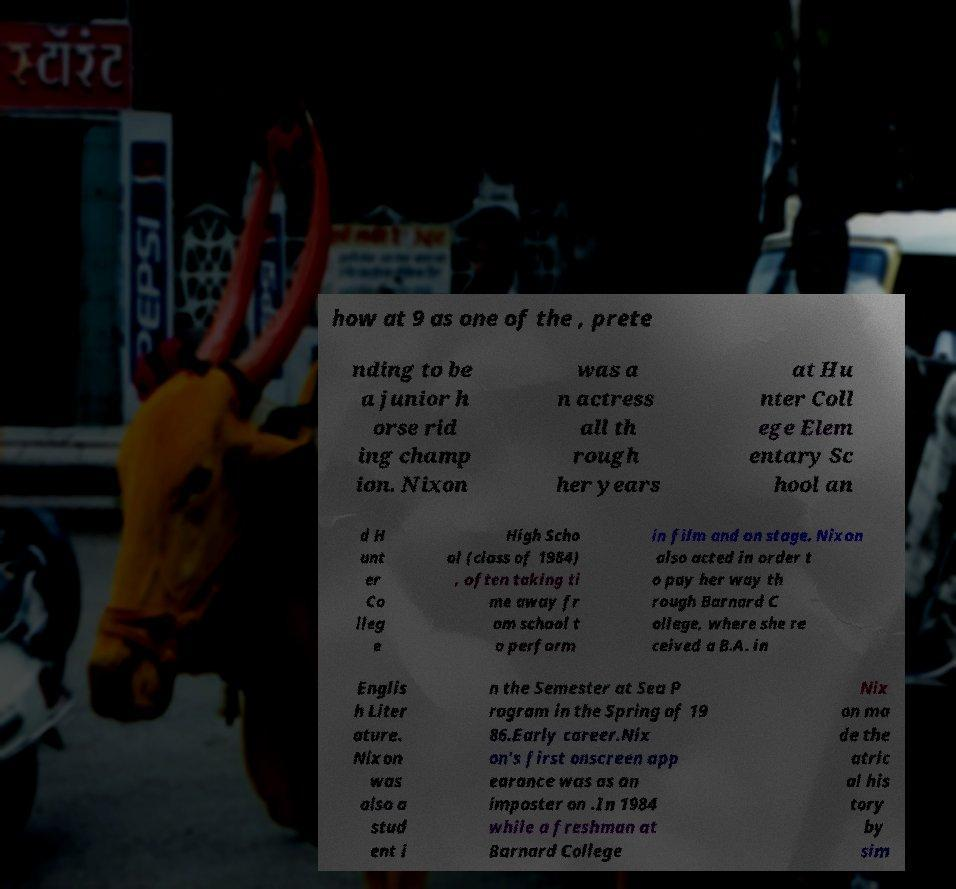There's text embedded in this image that I need extracted. Can you transcribe it verbatim? how at 9 as one of the , prete nding to be a junior h orse rid ing champ ion. Nixon was a n actress all th rough her years at Hu nter Coll ege Elem entary Sc hool an d H unt er Co lleg e High Scho ol (class of 1984) , often taking ti me away fr om school t o perform in film and on stage. Nixon also acted in order t o pay her way th rough Barnard C ollege, where she re ceived a B.A. in Englis h Liter ature. Nixon was also a stud ent i n the Semester at Sea P rogram in the Spring of 19 86.Early career.Nix on's first onscreen app earance was as an imposter on .In 1984 while a freshman at Barnard College Nix on ma de the atric al his tory by sim 